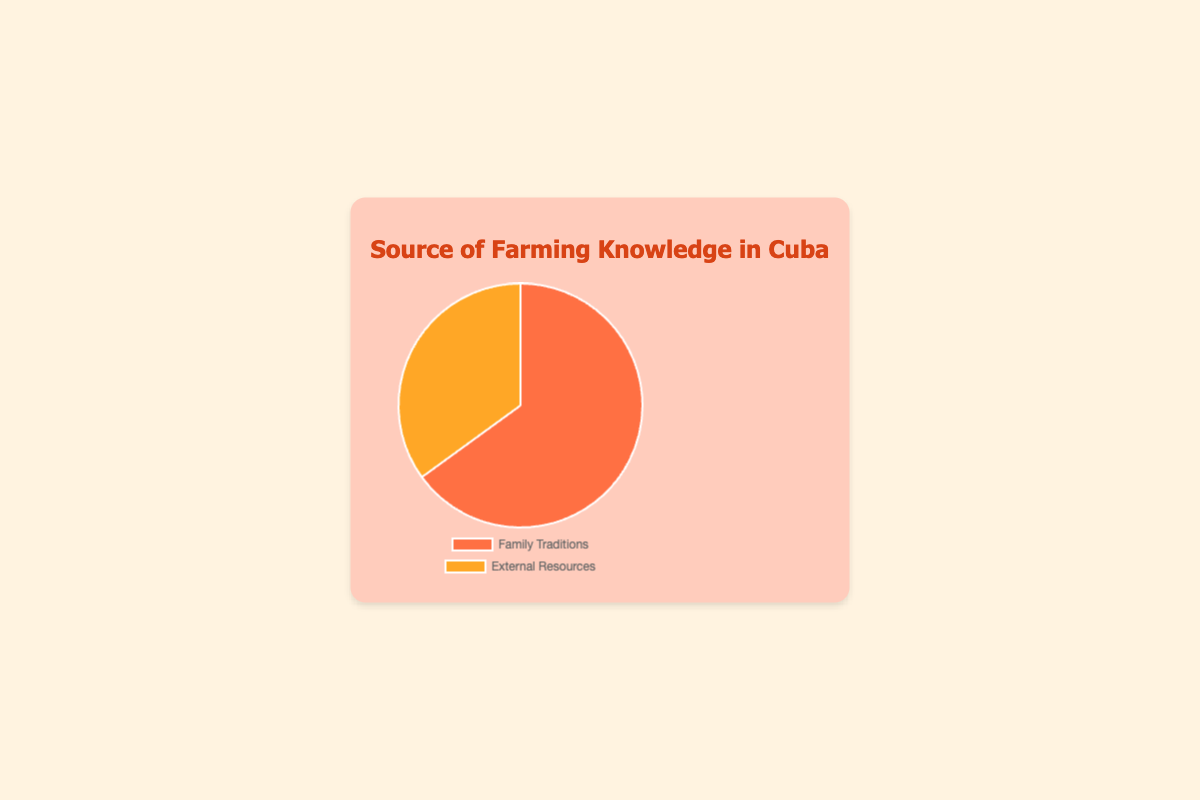What percentage of farming knowledge comes from family traditions? The chart shows that 65% of farming knowledge comes from family traditions, which is visible in the portion of the pie chart labeled "Family Traditions."
Answer: 65% What is the percentage of farming knowledge obtained from external resources? According to the pie chart, 35% of farming knowledge is sourced from external resources, which is represented in the segment labeled "External Resources."
Answer: 35% What is the difference in percentage between knowledge from family traditions and external resources? The difference can be found by subtracting the percentage of external resources (35%) from family traditions (65%): 65% - 35% = 30%.
Answer: 30% Which source of farming knowledge is more prevalent? We can see from the pie chart that family traditions account for 65%, whereas external resources account for 35%. Thus, family traditions are more prevalent.
Answer: Family traditions What fraction of farming knowledge comes from external resources, expressed as a fraction of the whole? The pie chart shows external resources as 35% of the total. To convert this to a fraction: 35% = 35/100 = 7/20.
Answer: 7/20 If we represent the amount of knowledge from family traditions in a room of 100 farmers, how many farmers are there? The chart indicates that 65% of farming knowledge is from family traditions; therefore, in a room of 100 farmers, 65 of them would rely on family traditions: 65% of 100 farmers = 65 farmers.
Answer: 65 farmers If we combined knowledge from both sources, what is the total percentage? This is a straightforward sum of the two data points: 65% (Family Traditions) + 35% (External Resources) = 100%.
Answer: 100% Out of a total 200 farmers, how many use external resources for their farming knowledge? To find this, we calculate 35% of 200 farmers: (35/100) * 200 = 70 farmers.
Answer: 70 farmers Which segment of the pie chart is colored orange? The chart uses colors to differentiate its segments. The external resources segment (35%) is colored orange.
Answer: External resources What is the ratio of knowledge from family traditions to external resources? The ratio can be determined by comparing the two percentages: Family Traditions (65%) to External Resources (35%) is 65:35, which simplifies to 13:7.
Answer: 13:7 